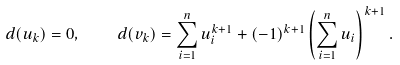<formula> <loc_0><loc_0><loc_500><loc_500>d ( u _ { k } ) = 0 , \quad d ( v _ { k } ) = \sum _ { i = 1 } ^ { n } u _ { i } ^ { k + 1 } + ( - 1 ) ^ { k + 1 } \left ( \sum _ { i = 1 } ^ { n } u _ { i } \right ) ^ { k + 1 } .</formula> 